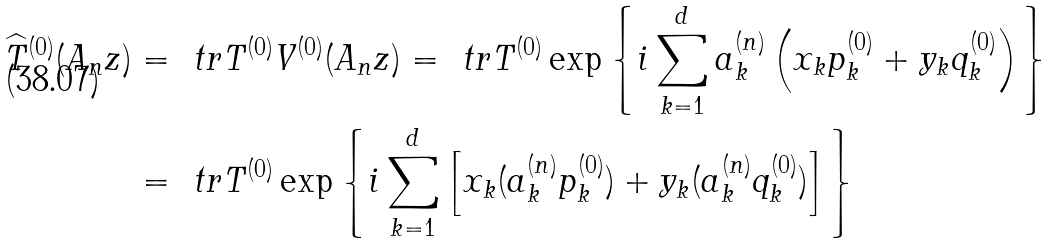<formula> <loc_0><loc_0><loc_500><loc_500>\widehat { T } ^ { ( 0 ) } ( A _ { n } z ) & = \ t r T ^ { ( 0 ) } V ^ { ( 0 ) } ( A _ { n } z ) = \ t r T ^ { ( 0 ) } \exp \left \{ i \sum ^ { d } _ { k = 1 } a _ { k } ^ { ( n ) } \left ( x _ { k } p ^ { ( 0 ) } _ { k } + y _ { k } q ^ { ( 0 ) } _ { k } \right ) \right \} \\ & = \ t r T ^ { ( 0 ) } \exp \left \{ i \sum ^ { d } _ { k = 1 } \left [ x _ { k } ( a _ { k } ^ { ( n ) } p ^ { ( 0 ) } _ { k } ) + y _ { k } ( a _ { k } ^ { ( n ) } q ^ { ( 0 ) } _ { k } ) \right ] \right \}</formula> 